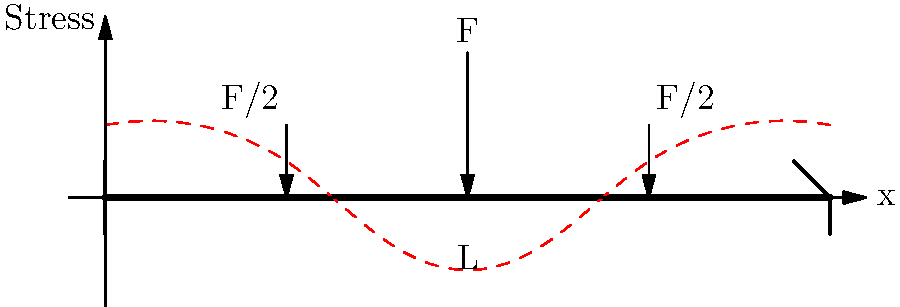A simply supported beam of length $L$ is subjected to three point loads as shown in the figure. A load $F$ is applied at the center, and two loads of $F/2$ each are applied at distances $L/4$ from both ends. How does the bending stress distribution along the length of the beam differ from a beam with only a single central load $F$? Explain your reasoning in simple terms. Let's break this down step-by-step:

1. For a beam with only a central load $F$:
   - The maximum bending stress occurs at the center.
   - The stress distribution is symmetrical, decreasing linearly to zero at the supports.

2. For the given beam with three loads:
   - The total load is still $F$ ($F + F/2 + F/2 = 2F$), but it's distributed differently.
   - The maximum bending moment (and thus stress) still occurs at the center due to symmetry.

3. Effect of additional loads:
   - The two $F/2$ loads create additional bending moments.
   - These moments partially counteract the moment from the central load.

4. Resulting stress distribution:
   - The maximum stress at the center is reduced compared to the single load case.
   - The stress doesn't decrease linearly to zero at the supports.
   - There are small regions of positive stress near the supports due to the nearby $F/2$ loads.

5. Shape of the stress distribution:
   - It resembles a flattened 'M' shape (as shown by the red dashed line).
   - The stress is negative (compression) in the middle and positive (tension) near the ends.

6. Practical implication:
   - This load distribution results in a more uniform stress along the beam.
   - It's often more desirable as it utilizes the beam material more efficiently.
Answer: The stress distribution is more uniform, with reduced maximum stress at the center and small positive stresses near the supports, resembling a flattened 'M' shape. 